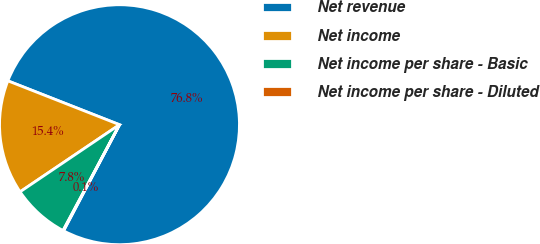Convert chart. <chart><loc_0><loc_0><loc_500><loc_500><pie_chart><fcel>Net revenue<fcel>Net income<fcel>Net income per share - Basic<fcel>Net income per share - Diluted<nl><fcel>76.76%<fcel>15.41%<fcel>7.75%<fcel>0.08%<nl></chart> 